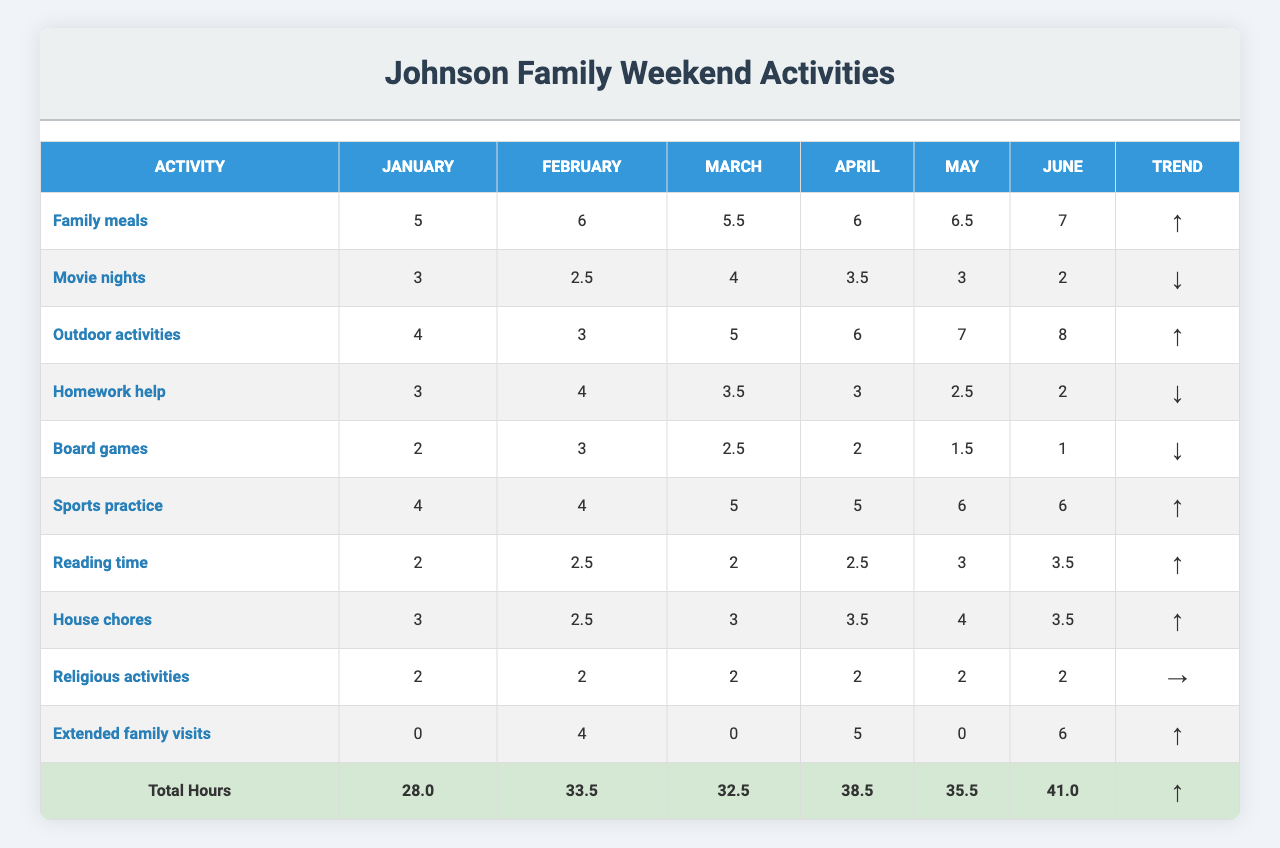What is the total number of hours spent on Family meals in March? In March, the hours spent on Family meals is 5.5. This is directly found in the table under March for Family meals.
Answer: 5.5 What is the average time allocated for Movie nights over the six months? The total hours for Movie nights are (3 + 2.5 + 4 + 3.5 + 3 + 2) = 18. The average is calculated as 18 divided by 6, which equals 3.
Answer: 3 Was there a time increase for Outdoor activities from January to June? In January, the hours for Outdoor activities were 4, and by June, it increased to 8. Since June's hours are more than January's, that indicates a time increase.
Answer: Yes How many hours are allocated to Homework help during the first three months combined? To find the total for Homework help in the first three months, we sum the hours: 3 + 4 + 3.5 = 10.5.
Answer: 10.5 Which activity had the highest total hours in June? In June, the activities and their hours are: Family meals (7), Movie nights (2), Outdoor activities (8), Homework help (2), Board games (1), Sports practice (6), Reading time (3.5), House chores (3.5), Religious activities (2), Extended family visits (6). The highest is Outdoor activities with 8 hours.
Answer: Outdoor activities What is the trend for Sports practice over the six months? The hours for Sports practice are: 4, 4, 5, 5, 6, 6. Since the last value (6) is greater than the first (4), the trend shows an increase.
Answer: ↑ What is the total time spent on Extended family visits over the six months? The hours spent are: 0 + 4 + 0 + 5 + 0 + 6 = 15. Thus, the total time across six months is 15 hours.
Answer: 15 Which weekend activity saw the largest increase in hours from January to June? To find this, we compare the hours for each activity in January and June. The largest increase is for Outdoor activities: from 4 to 8, an increase of 4 hours.
Answer: Outdoor activities What were the total hours across all activities in February? Summing the hours for all activities in February: 6 + 2.5 + 3 + 4 + 3 + 4 + 2.5 + 2 + 4 = 32.
Answer: 32 Is the total allocation for House chores greater than the allocation for Board games over the six months? House chores total (3 + 2.5 + 3 + 3.5 + 4 + 3.5) = 19.5 and Board games total (2 + 3 + 2.5 + 2 + 1.5 + 1) = 12.5. Since 19.5 is greater than 12.5, it confirms that House chores had a higher total.
Answer: Yes 